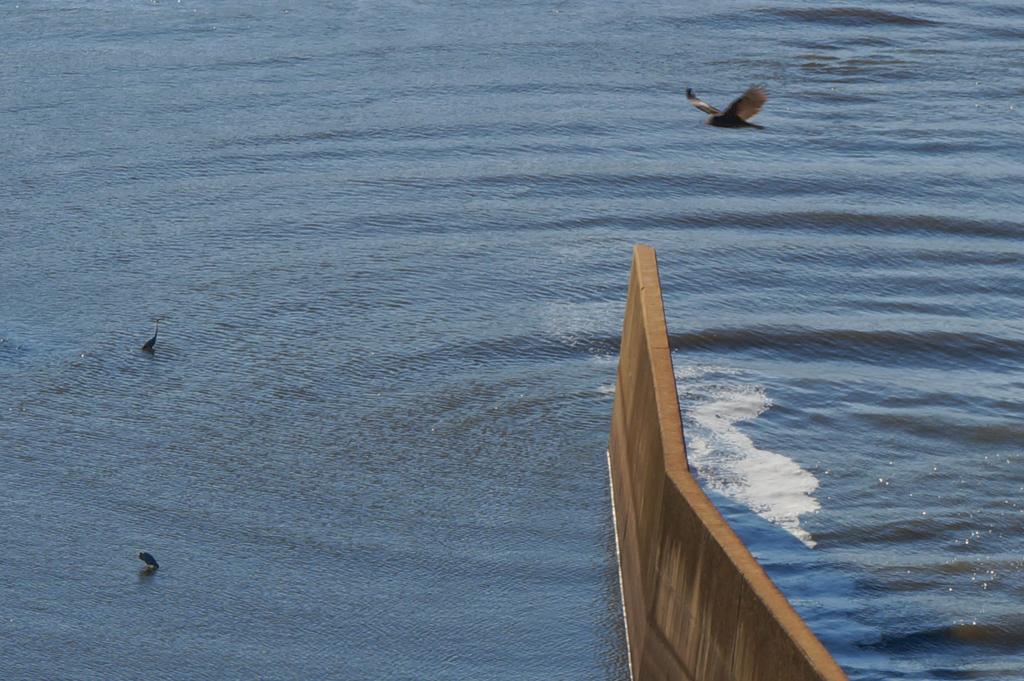Could you give a brief overview of what you see in this image? In this image we can see water. On the water there are two birds. One bird is flying. At the bottom we can see a wall. 